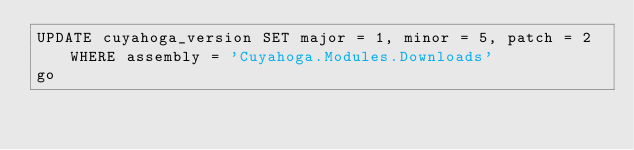<code> <loc_0><loc_0><loc_500><loc_500><_SQL_>UPDATE cuyahoga_version SET major = 1, minor = 5, patch = 2 WHERE assembly = 'Cuyahoga.Modules.Downloads'
go</code> 